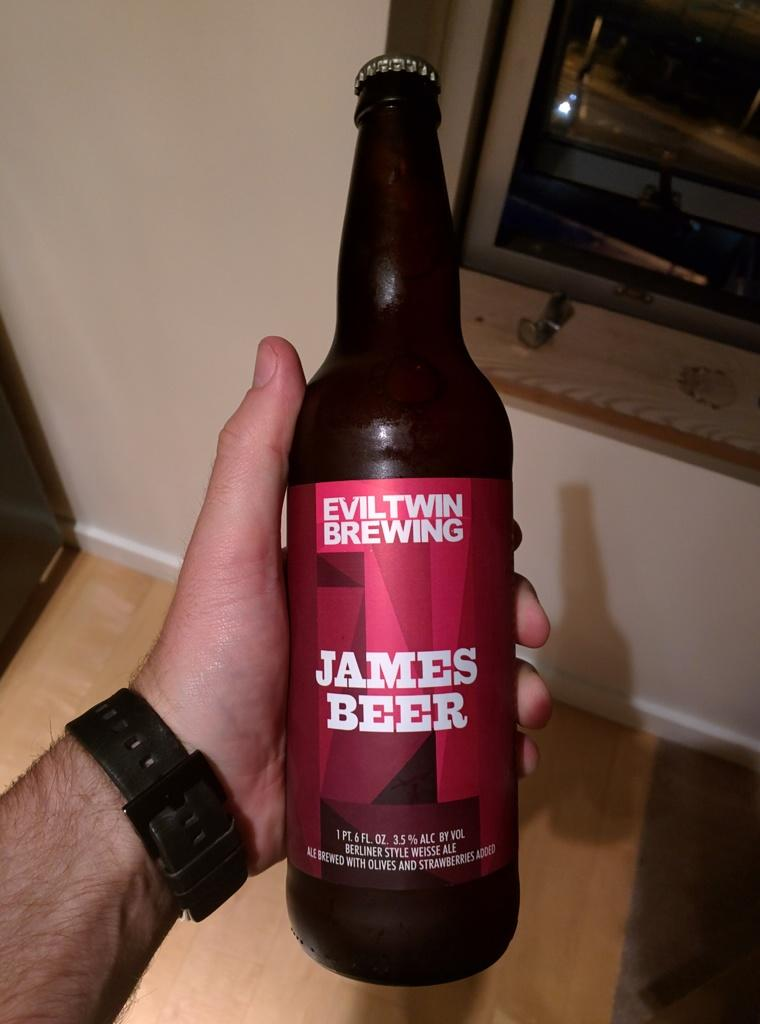<image>
Present a compact description of the photo's key features. The James Beer here is from Eviltwin Brewing 